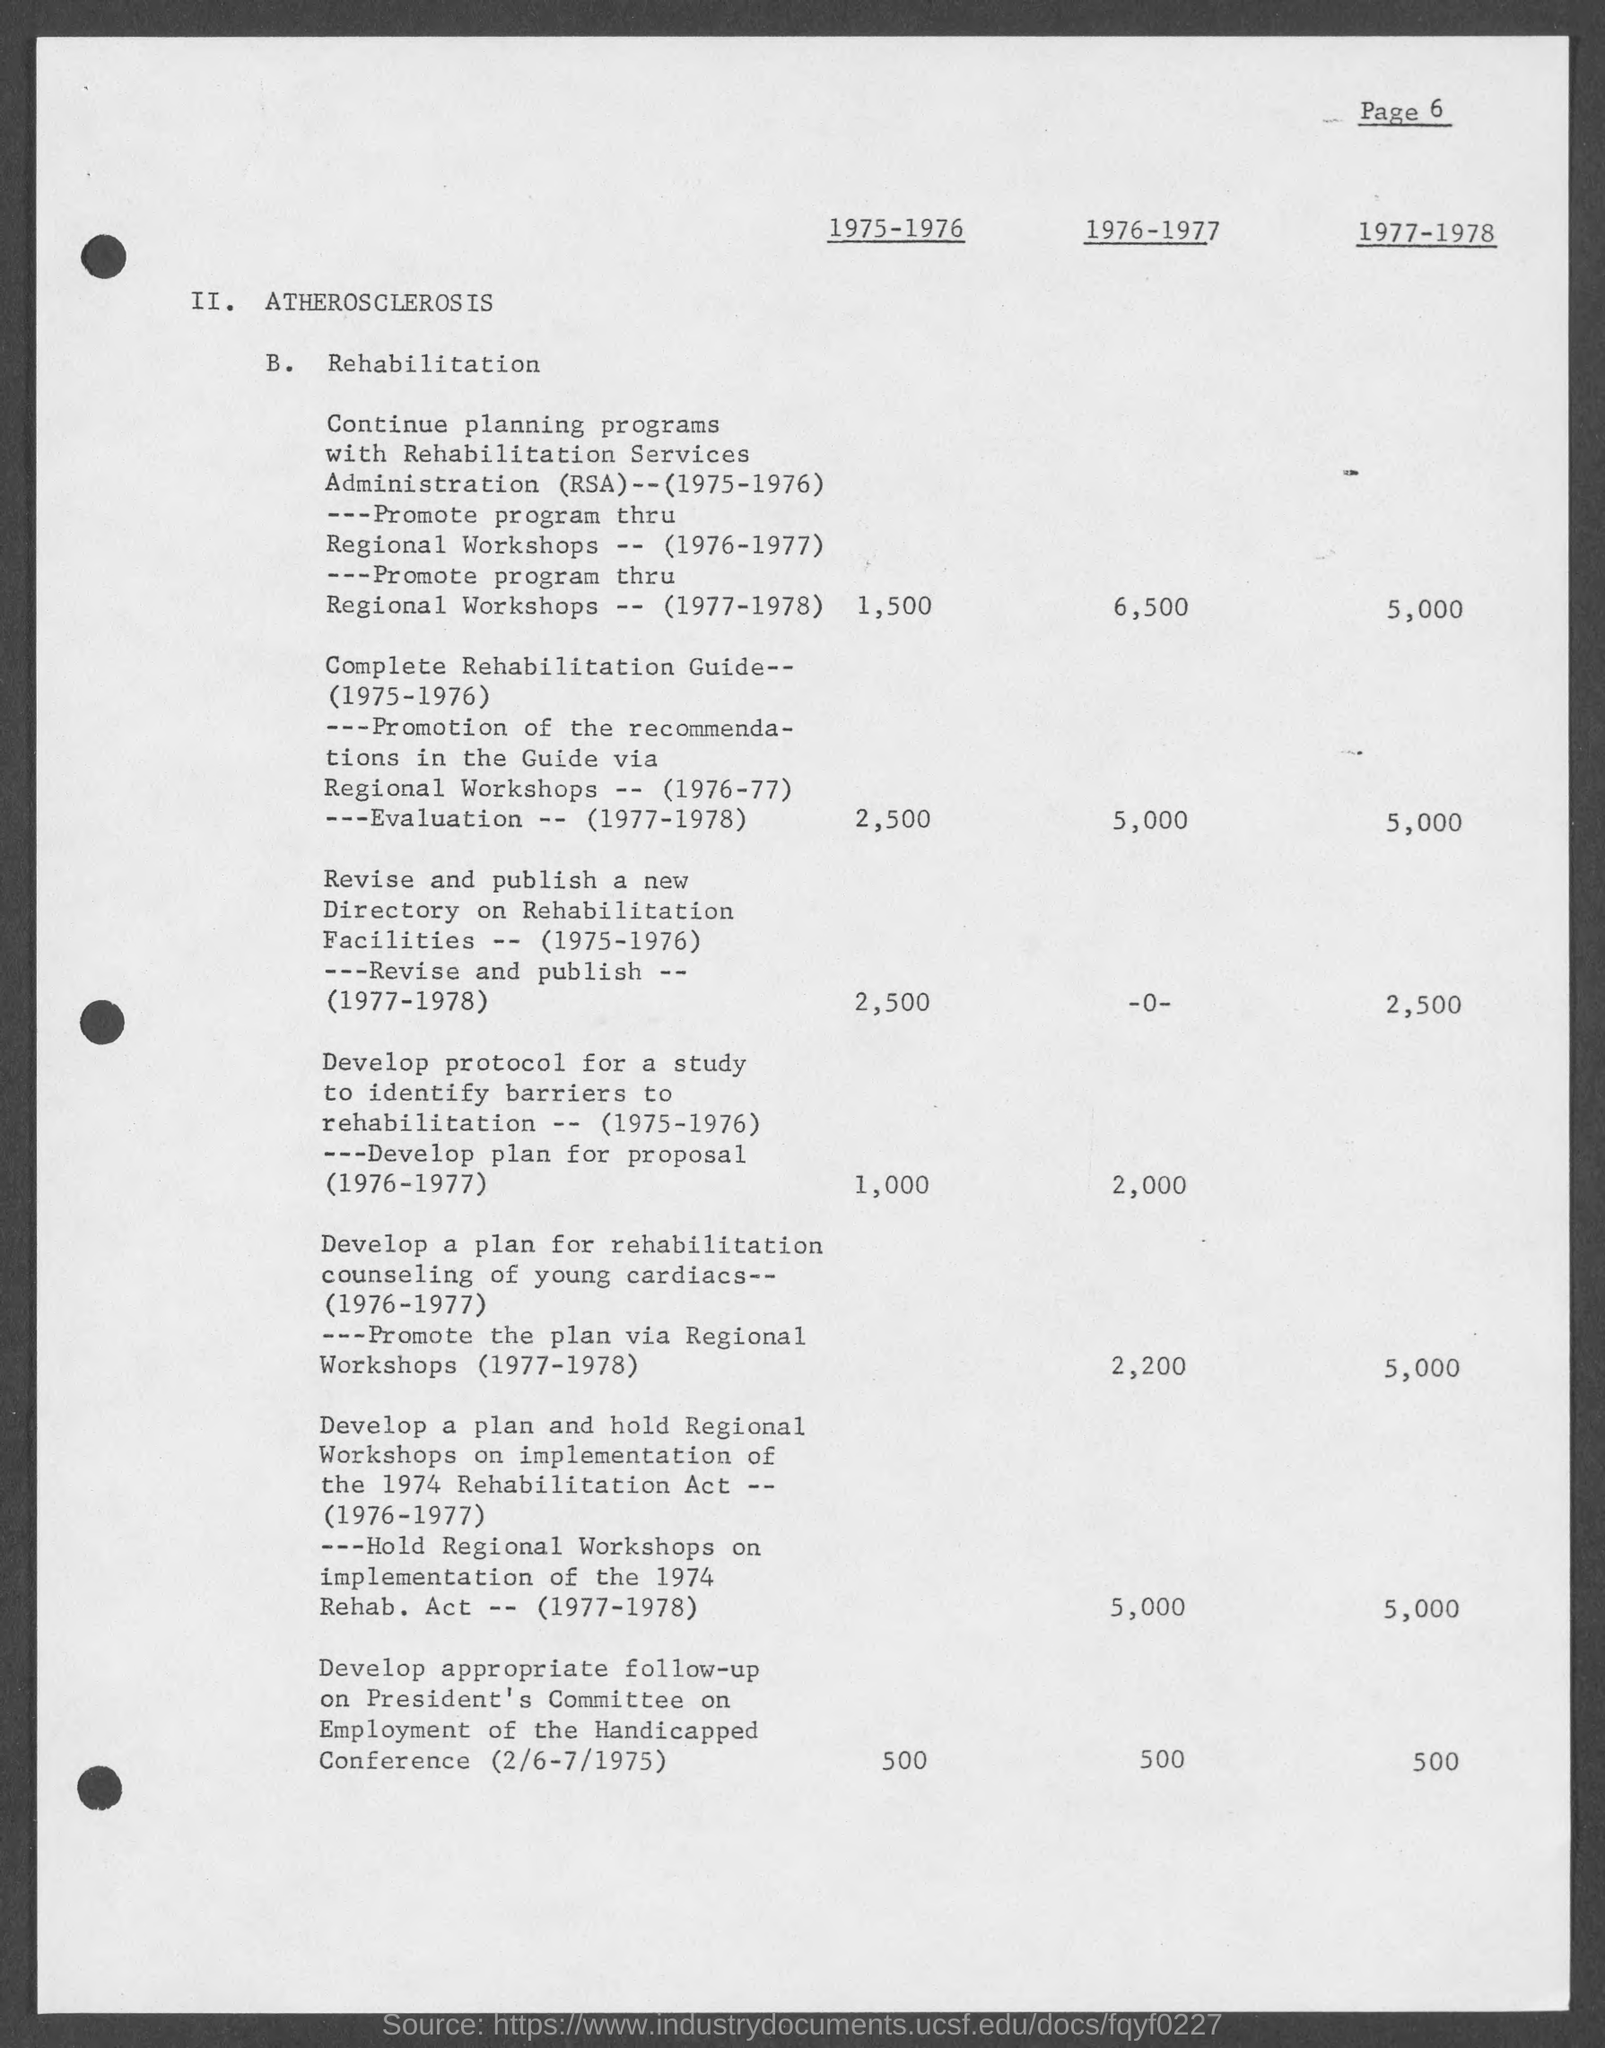Which page is this?
Provide a short and direct response. 6. What is point B.?
Offer a very short reply. Rehabilitation. 